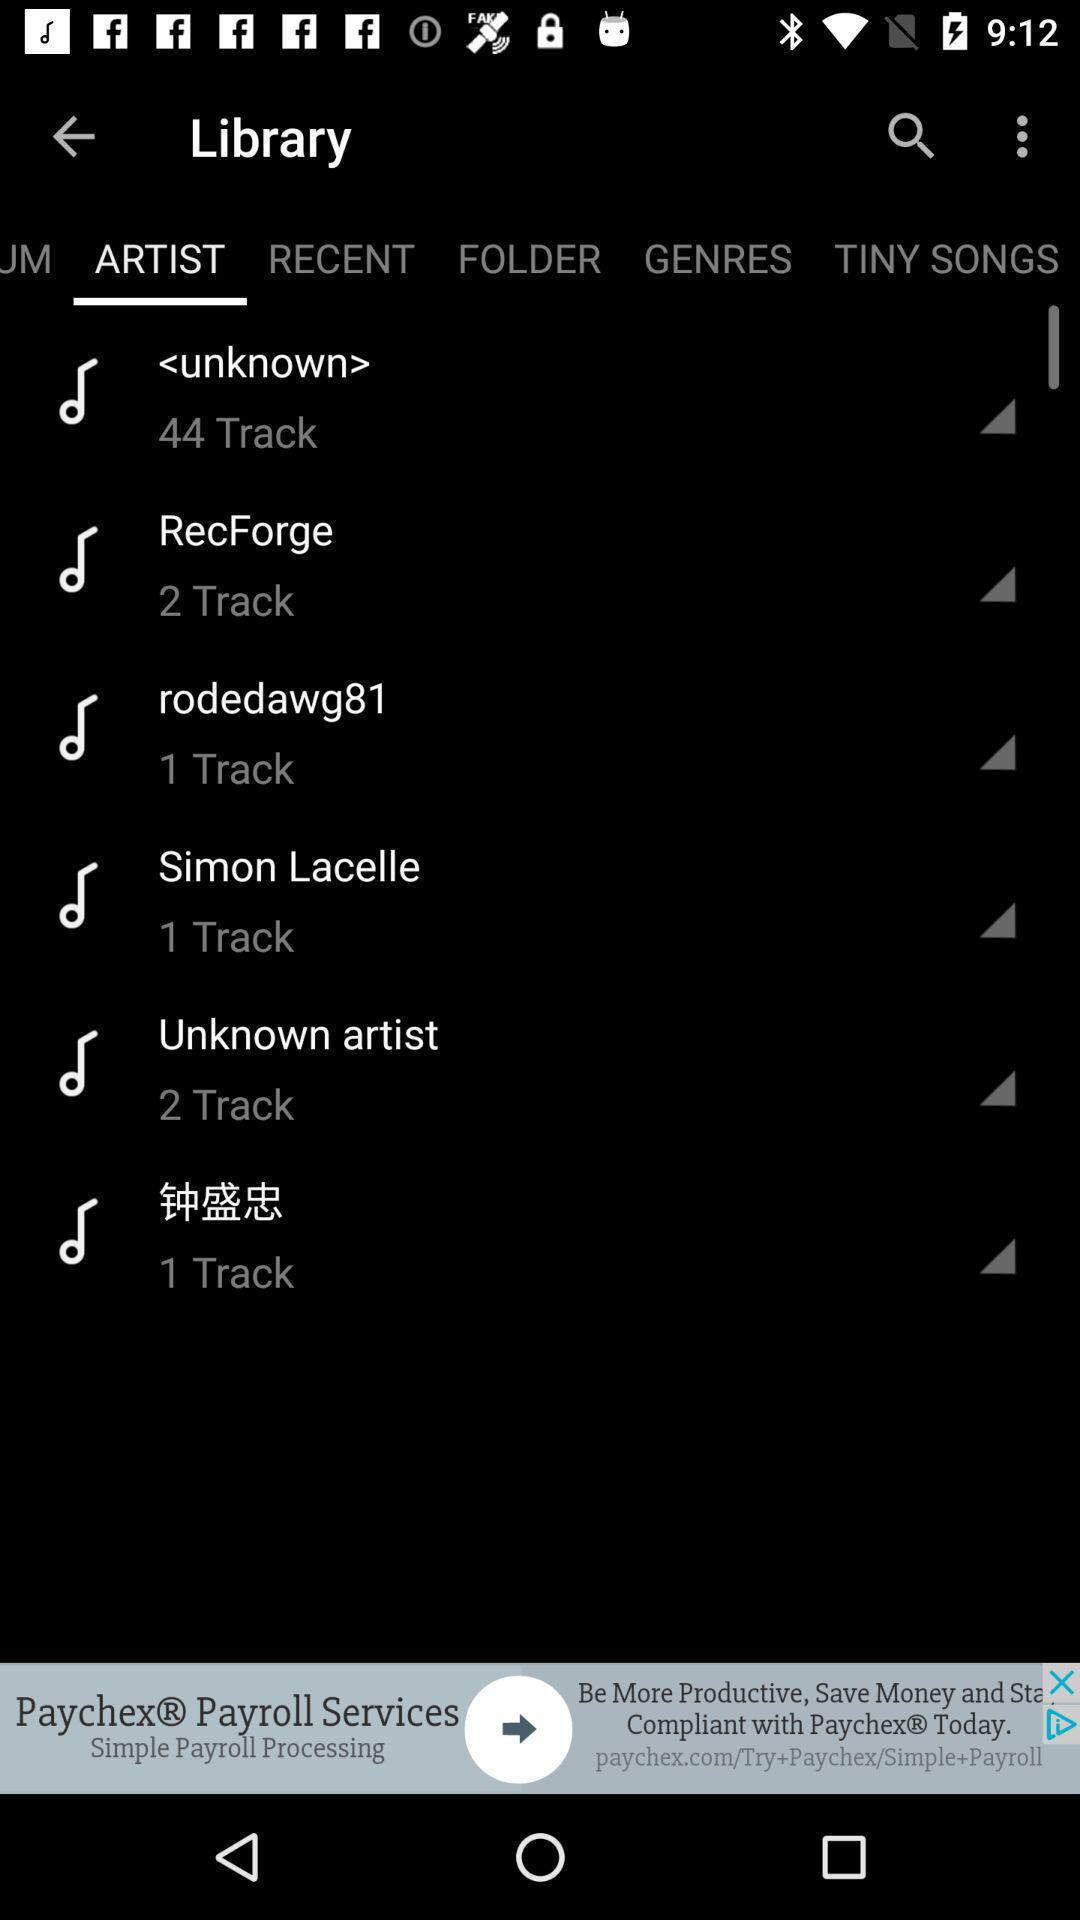How many tracks are there by "rodedawg81"? There is 1 track by "rodedawg81". 